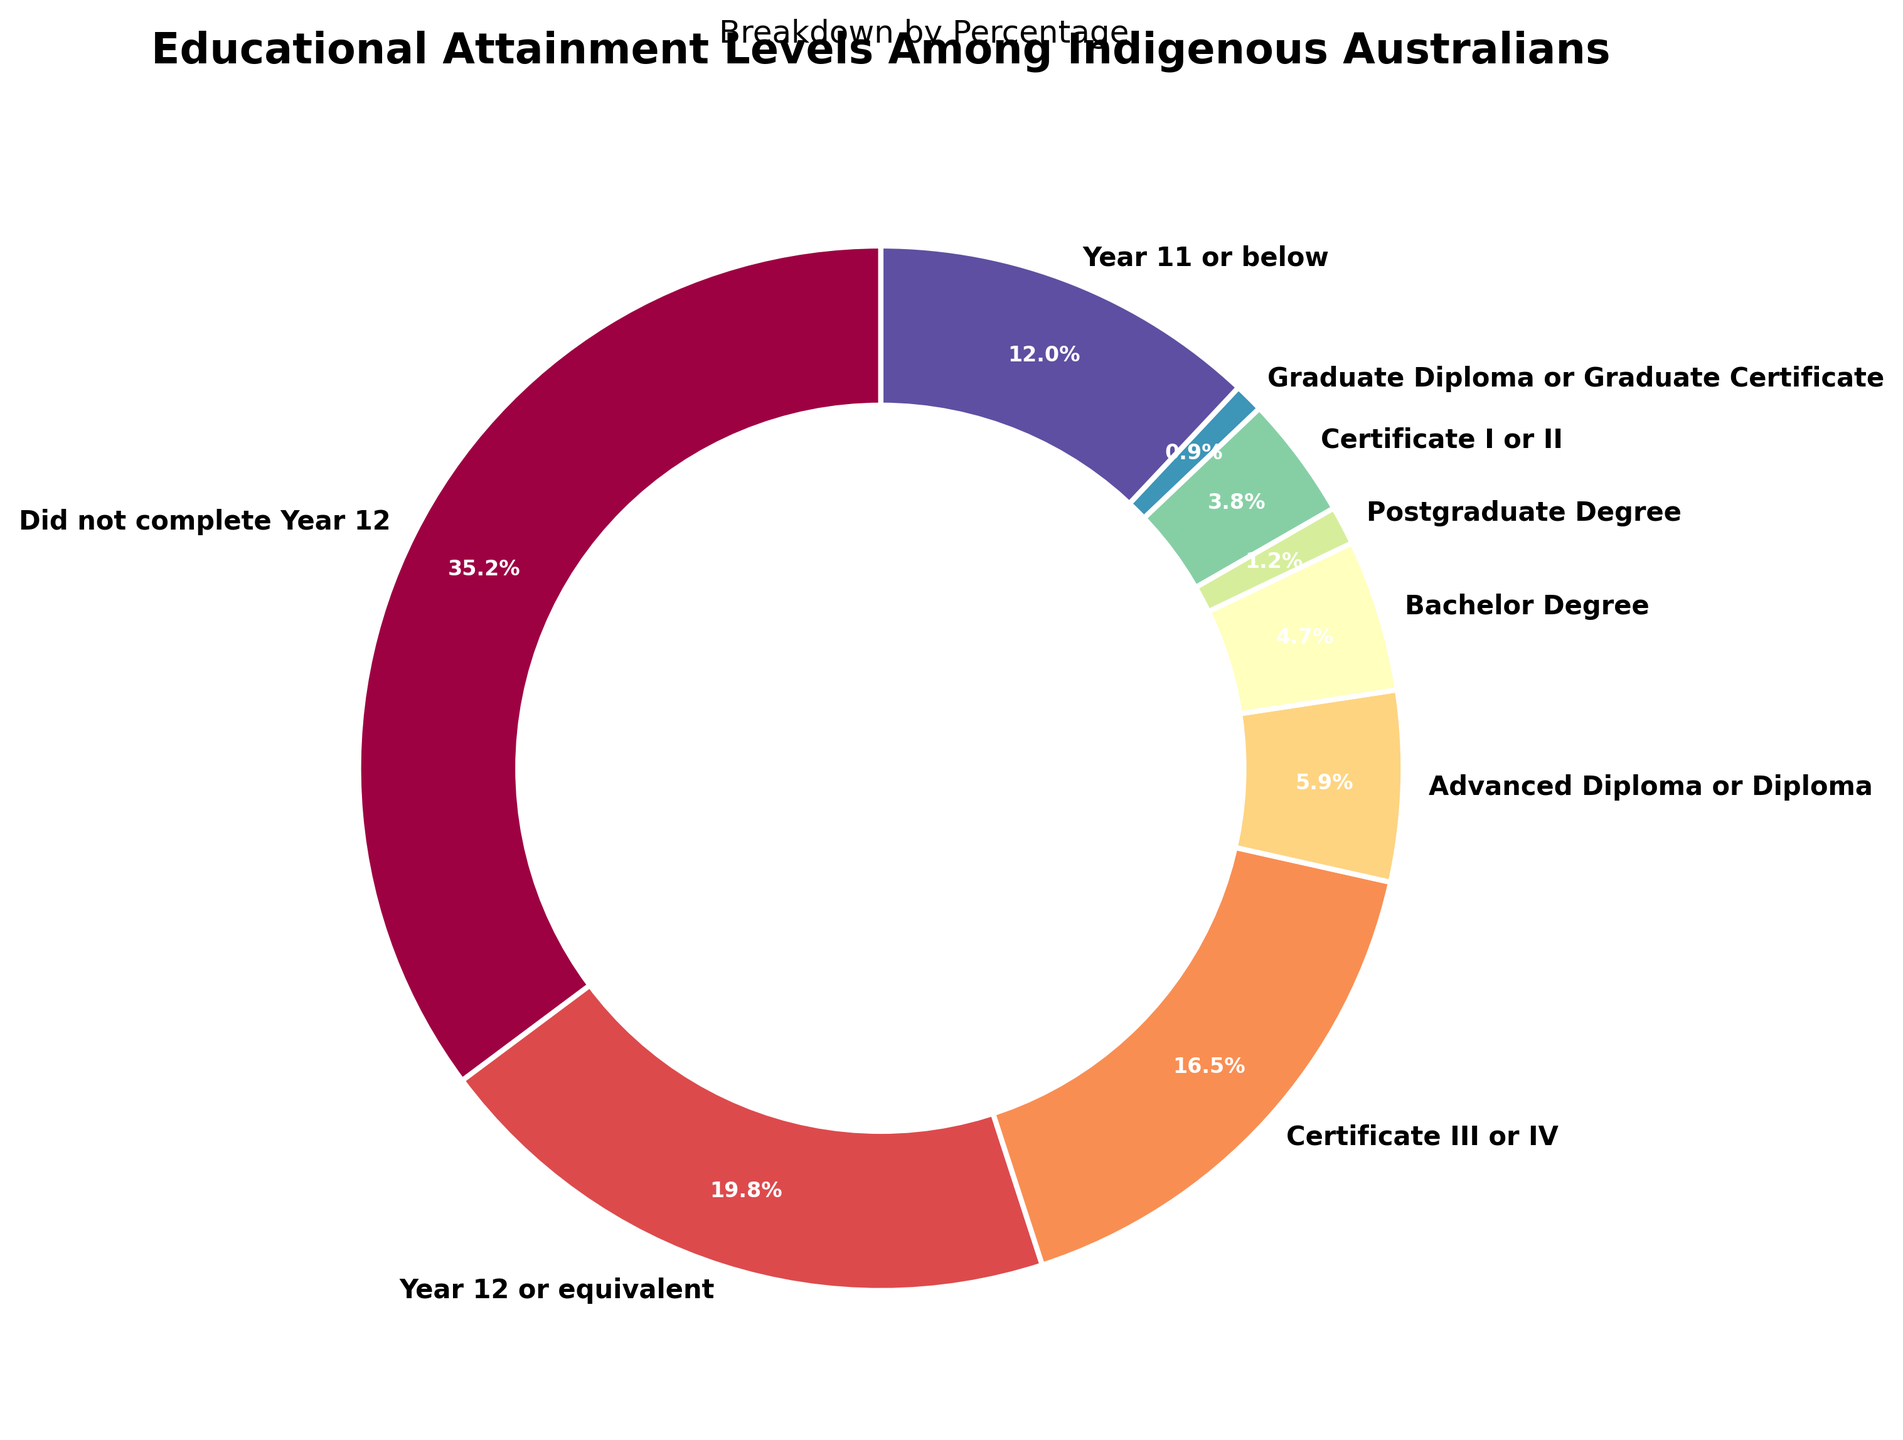Which educational attainment level has the highest percentage among Indigenous Australians? By looking at the pie chart, I can identify the largest segment which corresponds to "Did not complete Year 12" with a percentage of 35.2%.
Answer: Did not complete Year 12 How many educational attainment levels have a percentage above 10%? By examining the pie chart, I observe that the segments "Did not complete Year 12" (35.2%), "Year 12 or equivalent" (19.8%), "Certificate III or IV" (16.5%), and "Year 11 or below" (12.0%) all have percentages above 10%. Counting them gives a total of 4 educational attainment levels.
Answer: 4 What is the combined percentage of Indigenous Australians who have a Bachelor Degree or a Postgraduate Degree? From the pie chart, I see that the percentage for a Bachelor Degree is 4.7% and for a Postgraduate Degree is 1.2%. Adding these two values together, 4.7% + 1.2% = 5.9%.
Answer: 5.9% Which is more common among Indigenous Australians: holding a Certificate I or II or an Advanced Diploma or Diploma? According to the pie chart, the segment for "Certificate I or II" is 3.8% and for "Advanced Diploma or Diploma" is 5.9%. Therefore, holding an Advanced Diploma or Diploma is more common.
Answer: Advanced Diploma or Diploma What is the difference in percentage between the highest and the lowest educational attainment levels? Looking at the pie chart, the highest percentage is 35.2% (Did not complete Year 12) and the lowest is 0.9% (Graduate Diploma or Graduate Certificate). The difference is calculated as 35.2% - 0.9% = 34.3%.
Answer: 34.3% If I combine all individuals who have completed any form of tertiary education (Certificate III or IV, Advanced Diploma or Diploma, Bachelor Degree, Postgraduate Degree, and Graduate Diploma or Graduate Certificate), what is their total percentage? From the pie chart, the percentages for each are: Certificate III or IV (16.5%), Advanced Diploma or Diploma (5.9%), Bachelor Degree (4.7%), Postgraduate Degree (1.2%), and Graduate Diploma or Graduate Certificate (0.9%). Adding these values: 16.5% + 5.9% + 4.7% + 1.2% + 0.9% = 29.2%.
Answer: 29.2% Are there more Indigenous Australians who have completed Year 12 or equivalent compared to those who completed Year 11 or below? The pie chart shows that "Year 12 or equivalent" is 19.8% and "Year 11 or below" is 12.0%. Hence, there are more Indigenous Australians who completed Year 12 or equivalent.
Answer: Yes What percentage of Indigenous Australians have not completed Year 12? The pie chart clearly shows that the segment "Did not complete Year 12" represents 35.2%.
Answer: 35.2% What is the ratio of Indigenous Australians with a Graduate Diploma or Graduate Certificate to those with a Bachelor Degree? From the pie chart, the percentage of those with a Graduate Diploma or Graduate Certificate is 0.9%, and those with a Bachelor Degree is 4.7%. The ratio is calculated as 0.9% / 4.7%.
Answer: 0.19 (approximately) 